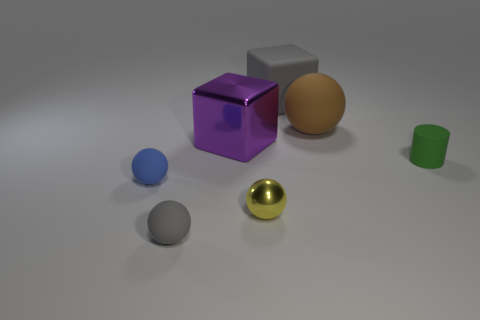There is a small object that is the same color as the big rubber cube; what shape is it?
Offer a terse response. Sphere. Is the color of the big rubber cube the same as the small matte object in front of the tiny yellow metal object?
Provide a short and direct response. Yes. How many other things are there of the same material as the brown object?
Provide a succinct answer. 4. Are there more tiny rubber balls than large brown rubber balls?
Your answer should be compact. Yes. There is a small sphere in front of the small yellow sphere; is it the same color as the large matte block?
Provide a succinct answer. Yes. The small shiny thing has what color?
Provide a succinct answer. Yellow. There is a big matte thing that is behind the brown rubber sphere; are there any shiny spheres that are in front of it?
Offer a terse response. Yes. There is a gray thing in front of the object that is to the right of the large brown matte sphere; what shape is it?
Ensure brevity in your answer.  Sphere. Is the number of metallic blocks less than the number of big matte objects?
Make the answer very short. Yes. Is the cylinder made of the same material as the large ball?
Keep it short and to the point. Yes. 